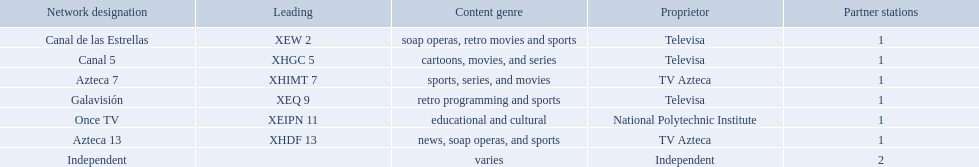What station shows cartoons? Canal 5. What station shows soap operas? Canal de las Estrellas. What station shows sports? Azteca 7. What stations show sports? Soap operas, retro movies and sports, retro programming and sports, news, soap operas, and sports. What of these is not affiliated with televisa? Azteca 7. Which owner only owns one network? National Polytechnic Institute, Independent. Of those, what is the network name? Once TV, Independent. Of those, which programming type is educational and cultural? Once TV. 